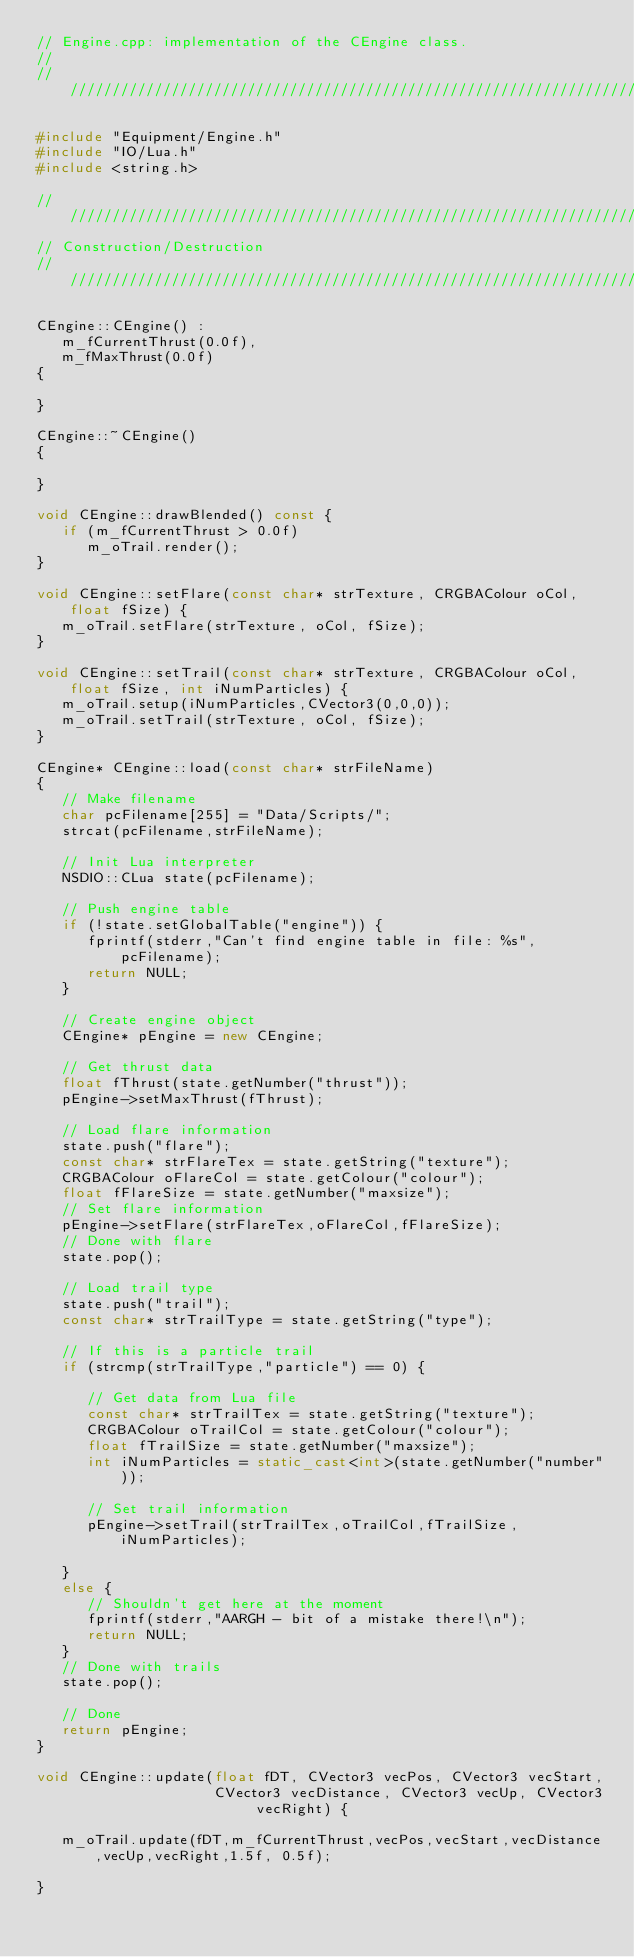<code> <loc_0><loc_0><loc_500><loc_500><_C++_>// Engine.cpp: implementation of the CEngine class.
//
//////////////////////////////////////////////////////////////////////

#include "Equipment/Engine.h"
#include "IO/Lua.h"
#include <string.h>

//////////////////////////////////////////////////////////////////////
// Construction/Destruction
//////////////////////////////////////////////////////////////////////

CEngine::CEngine() :
   m_fCurrentThrust(0.0f),
   m_fMaxThrust(0.0f)
{

}

CEngine::~CEngine()
{

}

void CEngine::drawBlended() const {
   if (m_fCurrentThrust > 0.0f)
      m_oTrail.render();
}

void CEngine::setFlare(const char* strTexture, CRGBAColour oCol, float fSize) {
   m_oTrail.setFlare(strTexture, oCol, fSize);   
}

void CEngine::setTrail(const char* strTexture, CRGBAColour oCol, float fSize, int iNumParticles) {
   m_oTrail.setup(iNumParticles,CVector3(0,0,0));
   m_oTrail.setTrail(strTexture, oCol, fSize);
}

CEngine* CEngine::load(const char* strFileName) 
{
   // Make filename
   char pcFilename[255] = "Data/Scripts/";
   strcat(pcFilename,strFileName);
   
   // Init Lua interpreter
   NSDIO::CLua state(pcFilename);
   
   // Push engine table
   if (!state.setGlobalTable("engine")) {
      fprintf(stderr,"Can't find engine table in file: %s",pcFilename);
      return NULL;
   }

   // Create engine object
   CEngine* pEngine = new CEngine;

   // Get thrust data
   float fThrust(state.getNumber("thrust"));
   pEngine->setMaxThrust(fThrust);

   // Load flare information
   state.push("flare");
   const char* strFlareTex = state.getString("texture");
   CRGBAColour oFlareCol = state.getColour("colour");
   float fFlareSize = state.getNumber("maxsize");
   // Set flare information
   pEngine->setFlare(strFlareTex,oFlareCol,fFlareSize);
   // Done with flare
   state.pop();

   // Load trail type
   state.push("trail");
   const char* strTrailType = state.getString("type");

   // If this is a particle trail
   if (strcmp(strTrailType,"particle") == 0) {

      // Get data from Lua file
      const char* strTrailTex = state.getString("texture");
      CRGBAColour oTrailCol = state.getColour("colour");
      float fTrailSize = state.getNumber("maxsize");
      int iNumParticles = static_cast<int>(state.getNumber("number"));

      // Set trail information
      pEngine->setTrail(strTrailTex,oTrailCol,fTrailSize,iNumParticles);

   }
   else {
      // Shouldn't get here at the moment
      fprintf(stderr,"AARGH - bit of a mistake there!\n");
      return NULL;
   }
   // Done with trails
   state.pop();

   // Done
   return pEngine;
}

void CEngine::update(float fDT, CVector3 vecPos, CVector3 vecStart, 
                     CVector3 vecDistance, CVector3 vecUp, CVector3 vecRight) {

   m_oTrail.update(fDT,m_fCurrentThrust,vecPos,vecStart,vecDistance,vecUp,vecRight,1.5f, 0.5f);
   
}

</code> 